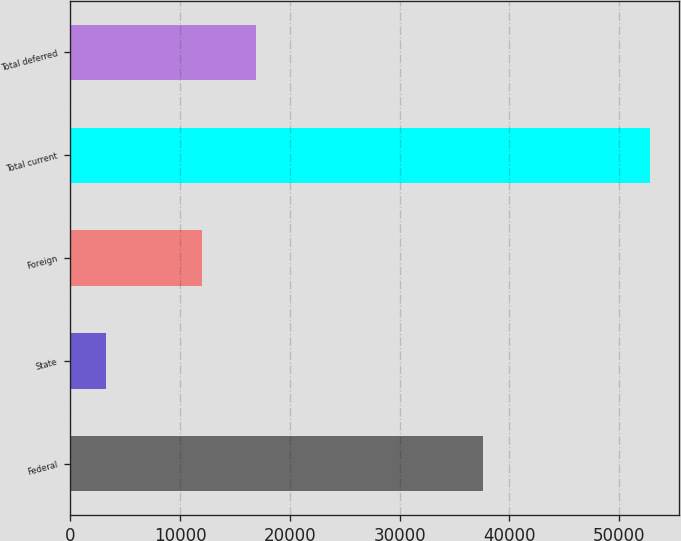Convert chart. <chart><loc_0><loc_0><loc_500><loc_500><bar_chart><fcel>Federal<fcel>State<fcel>Foreign<fcel>Total current<fcel>Total deferred<nl><fcel>37580<fcel>3268<fcel>11974<fcel>52822<fcel>16929.4<nl></chart> 